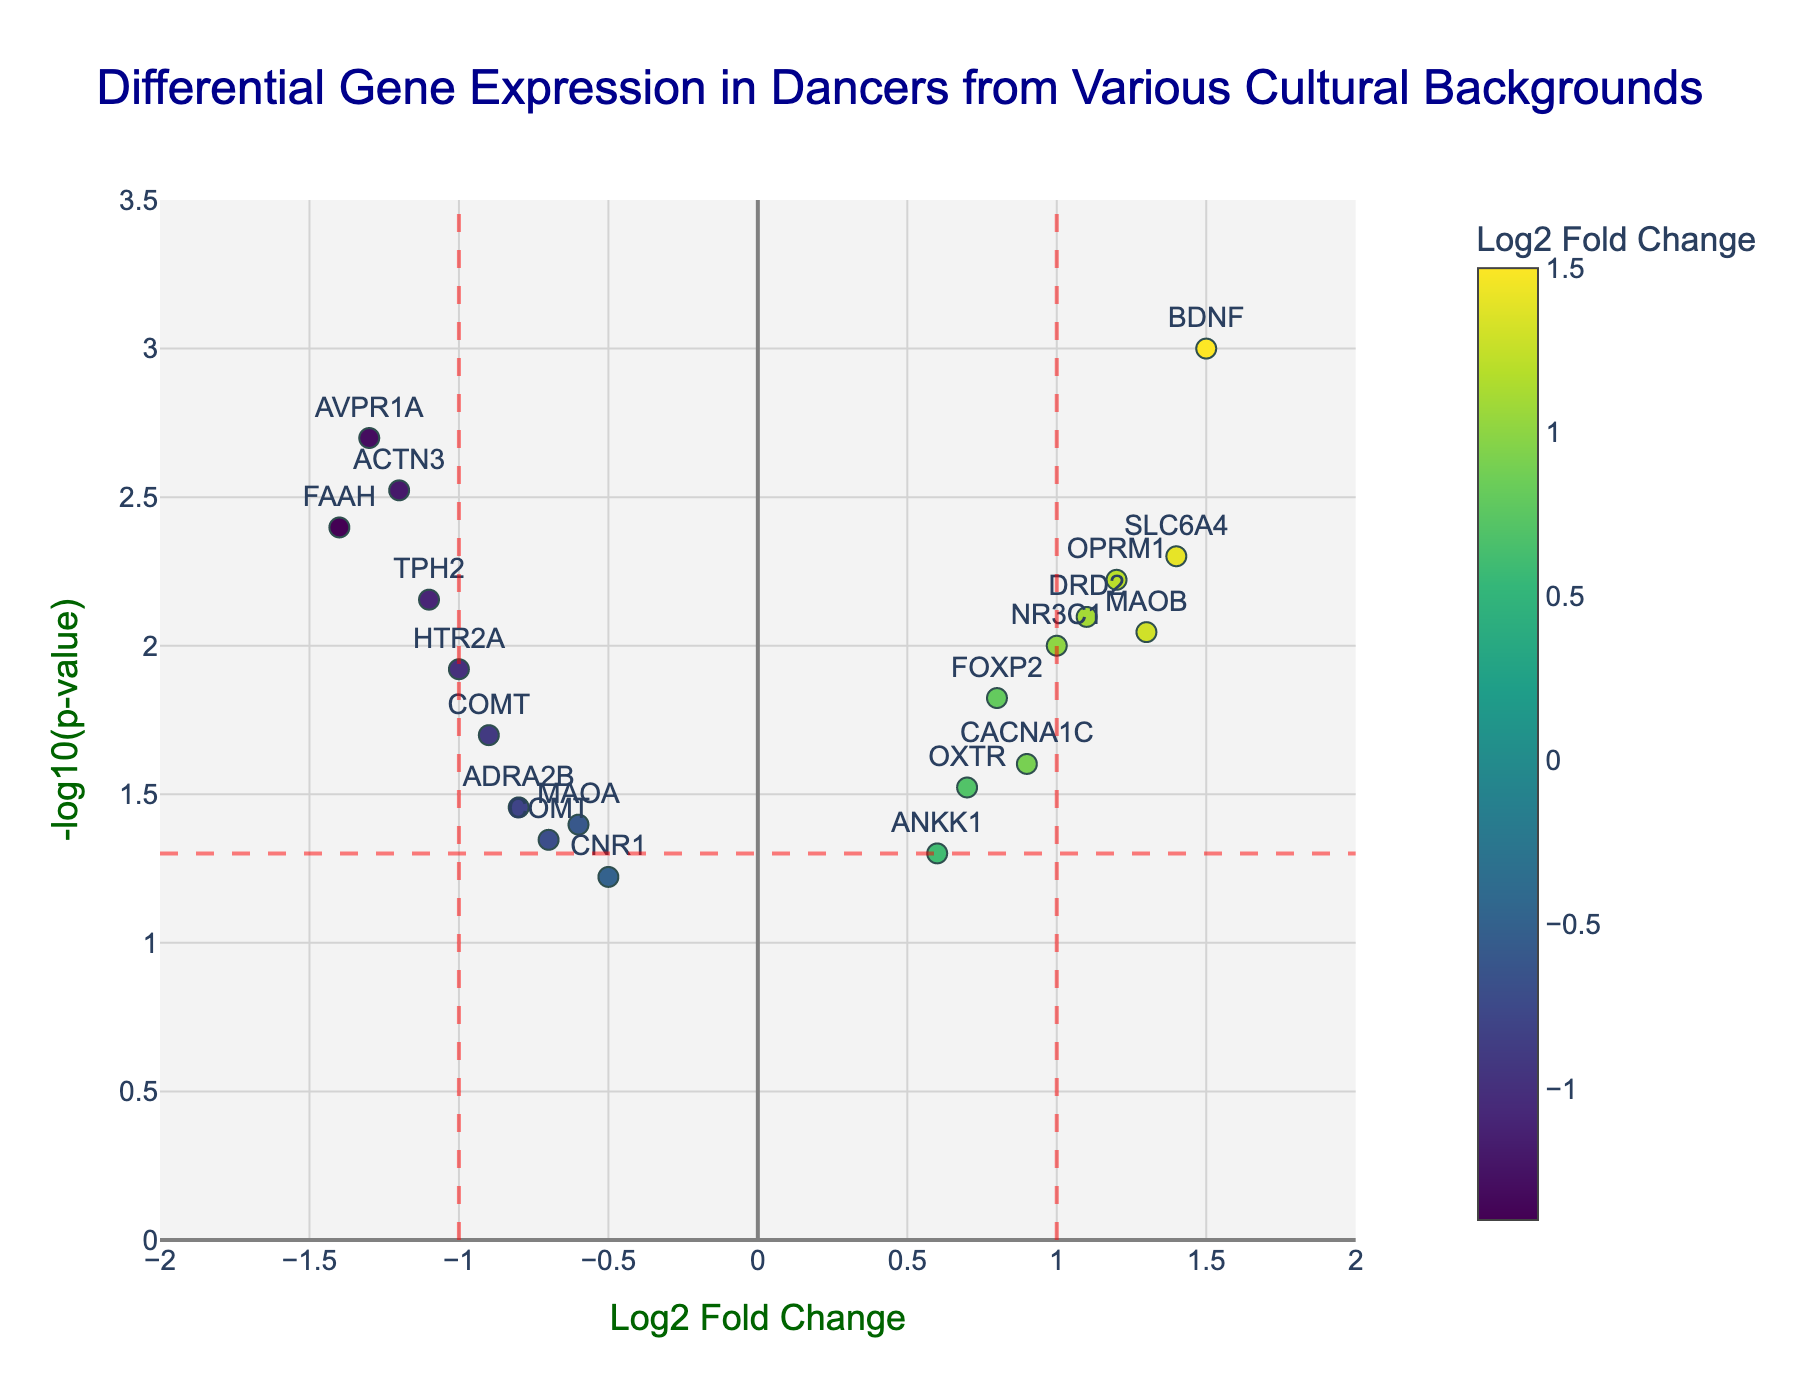How many genes are shown in this Volcano Plot? Count the number of unique points on the plot. Each point represents a gene.
Answer: 18 What is the significance threshold for the p-value in this Volcano Plot? Identify the location of the horizontal red dashed line on the y-axis. This threshold is where the p-value equals 0.05.
Answer: -log10(0.05) Which gene has the highest log2 Fold Change value? Look for the point farthest to the right on the x-axis. Check the hovertext or label to identify the gene.
Answer: BDNF Which gene has the lowest p-value? Look for the point highest on the y-axis. Check the hovertext or label for the gene name.
Answer: BDNF How many genes have a log2 Fold Change greater than 1? Count the number of points to the right of the vertical red dashed line at x=1.
Answer: 5 Which genes have both significant p-values (p < 0.05) and absolute log2 Fold Change values greater than 1? Identify the points above the horizontal red dashed line and either to the left of the vertical line at -1 or right of the vertical line at 1.
Answer: ACTN3, AVPR1A, FAAH, BDNF What is the log2 Fold Change and p-value of the gene TPH2? Find the TPH2 point and read the hovertext or label.
Answer: Log2FC: -1.1, p-value: 0.007 How many genes have p-values less than 0.01? Count the number of points above -log10(0.01) on the y-axis.
Answer: 6 Which gene has a log2 Fold Change closest to zero but still statistically significant (p < 0.05)? Identify the points close to the origin (0, 0) but above the horizontal red dashed line.
Answer: ANKK1 Which gene with a positive log2 Fold Change has the smallest p-value? Look at the points to the right of the y-axis and find the highest point.
Answer: BDNF 